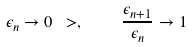<formula> <loc_0><loc_0><loc_500><loc_500>\epsilon _ { n } \to 0 \ > , \quad \frac { \epsilon _ { n + 1 } } { \epsilon _ { n } } \to 1</formula> 